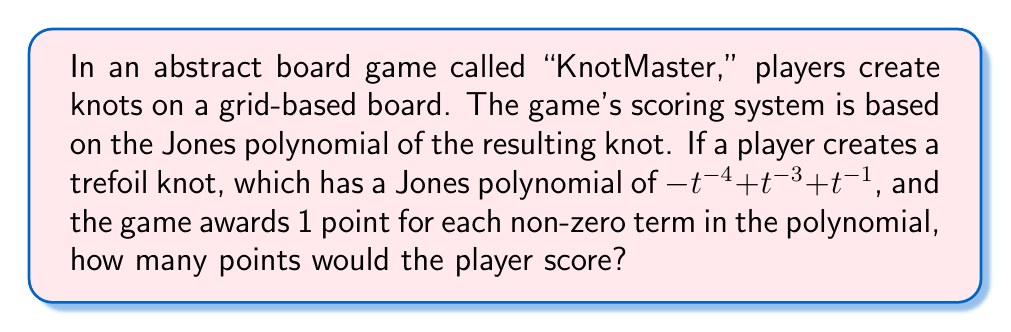Give your solution to this math problem. To solve this problem, we need to follow these steps:

1. Understand the Jones polynomial of the trefoil knot:
   The Jones polynomial for the trefoil knot is given as:
   $$-t^{-4} + t^{-3} + t^{-1}$$

2. Count the non-zero terms in the polynomial:
   a) $-t^{-4}$ is the first non-zero term
   b) $t^{-3}$ is the second non-zero term
   c) $t^{-1}$ is the third non-zero term

3. Apply the scoring system:
   The game awards 1 point for each non-zero term in the polynomial.
   Since we have identified 3 non-zero terms, the player would score 3 points.

This scoring system demonstrates a connection between knot theory (specifically, knot invariants like the Jones polynomial) and game mechanics, showing how mathematical concepts can be integrated into strategic board games.
Answer: 3 points 